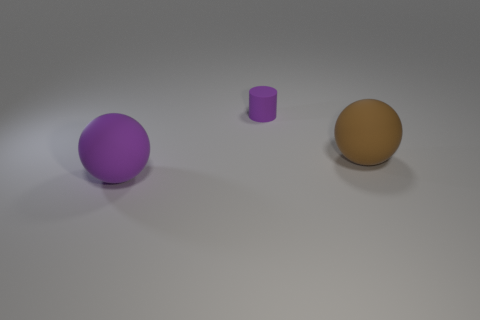Subtract all brown balls. Subtract all red blocks. How many balls are left? 1 Add 2 yellow shiny things. How many objects exist? 5 Subtract all cylinders. How many objects are left? 2 Subtract all large matte things. Subtract all big green metal objects. How many objects are left? 1 Add 1 large brown spheres. How many large brown spheres are left? 2 Add 2 tiny purple things. How many tiny purple things exist? 3 Subtract 0 cyan cubes. How many objects are left? 3 